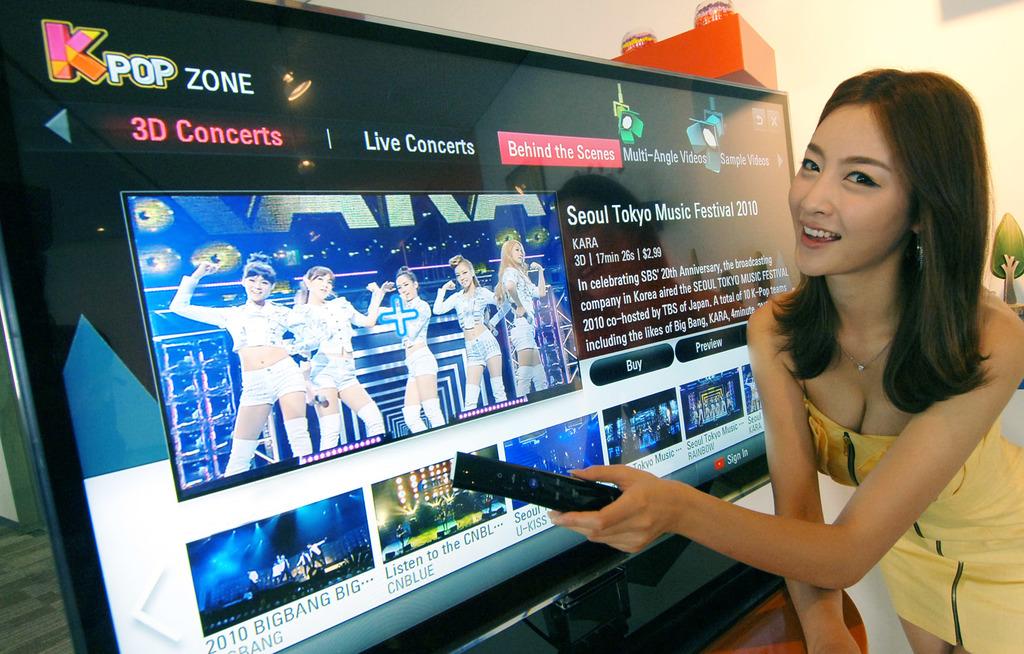What music festival is she watching?
Offer a terse response. Seoul tokyo. 